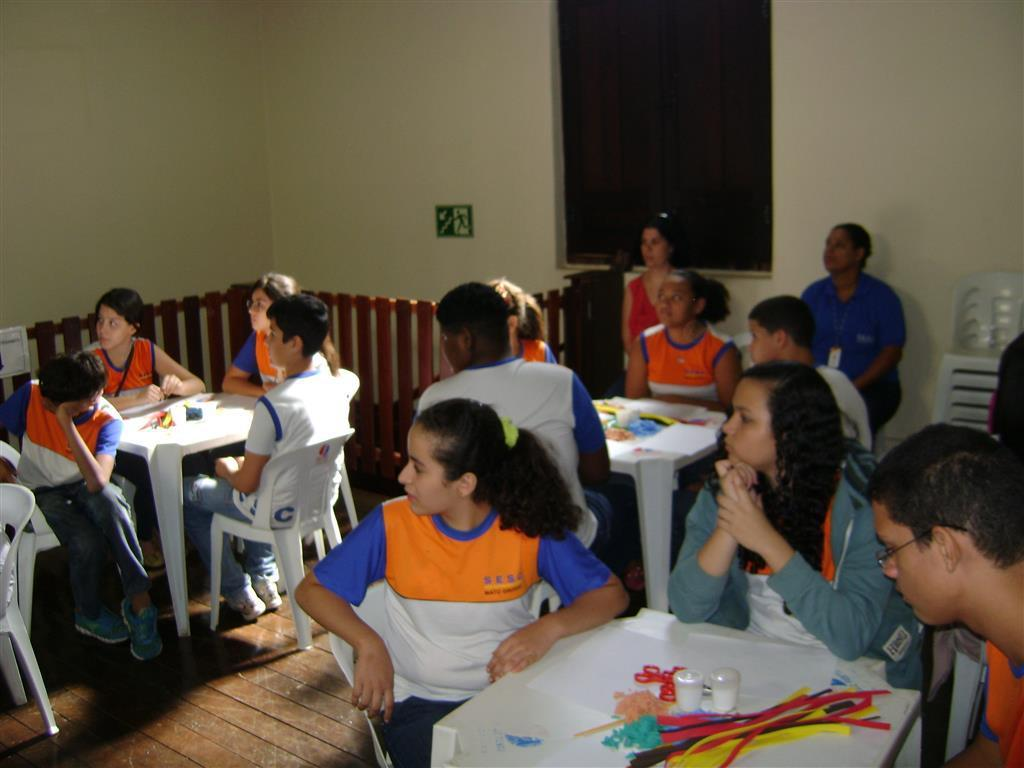What is the main subject of the image? The main subject of the image is a group of people. What are the people in the image doing? The people are sitting on chairs. Can you describe the arrangement of the chairs in the image? The chairs are in front of a table. What type of pancake is being served on the table in the image? There is no pancake present in the image. Can you tell me how many bottles are visible on the table in the image? There are no bottles visible on the table in the image. 